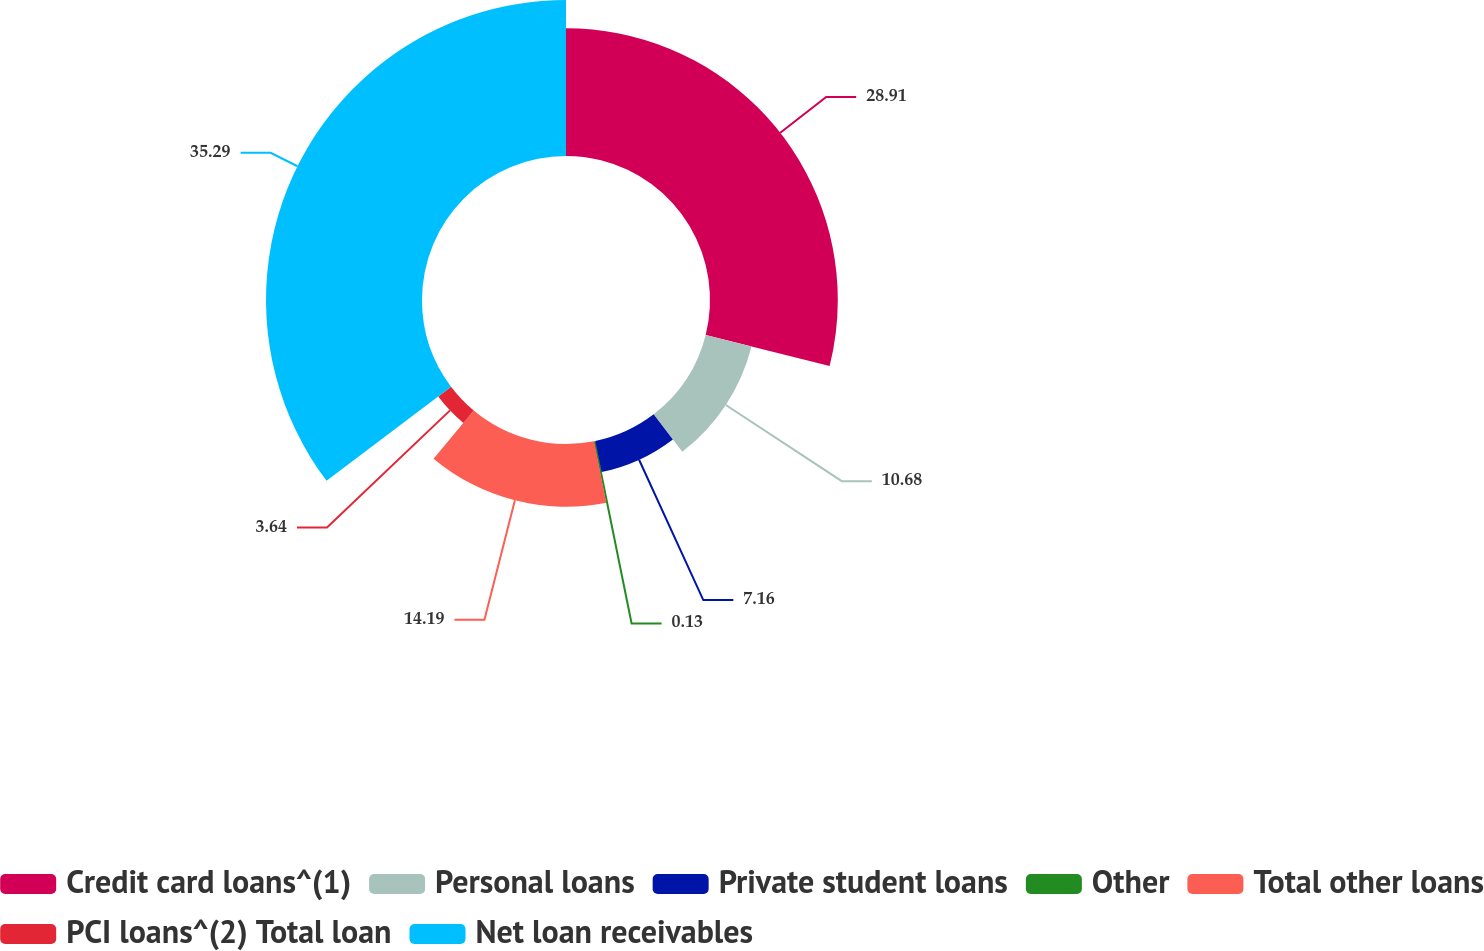Convert chart to OTSL. <chart><loc_0><loc_0><loc_500><loc_500><pie_chart><fcel>Credit card loans^(1)<fcel>Personal loans<fcel>Private student loans<fcel>Other<fcel>Total other loans<fcel>PCI loans^(2) Total loan<fcel>Net loan receivables<nl><fcel>28.91%<fcel>10.68%<fcel>7.16%<fcel>0.13%<fcel>14.19%<fcel>3.64%<fcel>35.29%<nl></chart> 